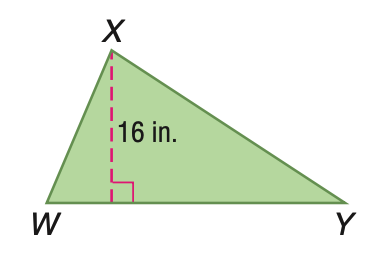Question: Triangle W X Y has an area of 248 square inches. Find the length of the base.
Choices:
A. 15.5
B. 16
C. 31
D. 32
Answer with the letter. Answer: C 